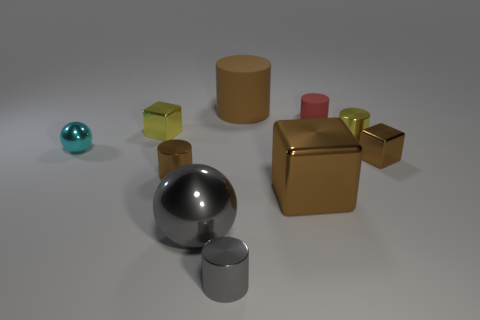Subtract all brown blocks. How many blocks are left? 1 Subtract all small yellow metal cubes. How many cubes are left? 2 Subtract all purple cylinders. Subtract all cyan cubes. How many cylinders are left? 5 Subtract all brown spheres. How many red cylinders are left? 1 Subtract all brown shiny objects. Subtract all matte cylinders. How many objects are left? 5 Add 5 yellow things. How many yellow things are left? 7 Add 2 large metallic blocks. How many large metallic blocks exist? 3 Subtract 1 red cylinders. How many objects are left? 9 Subtract all spheres. How many objects are left? 8 Subtract 1 spheres. How many spheres are left? 1 